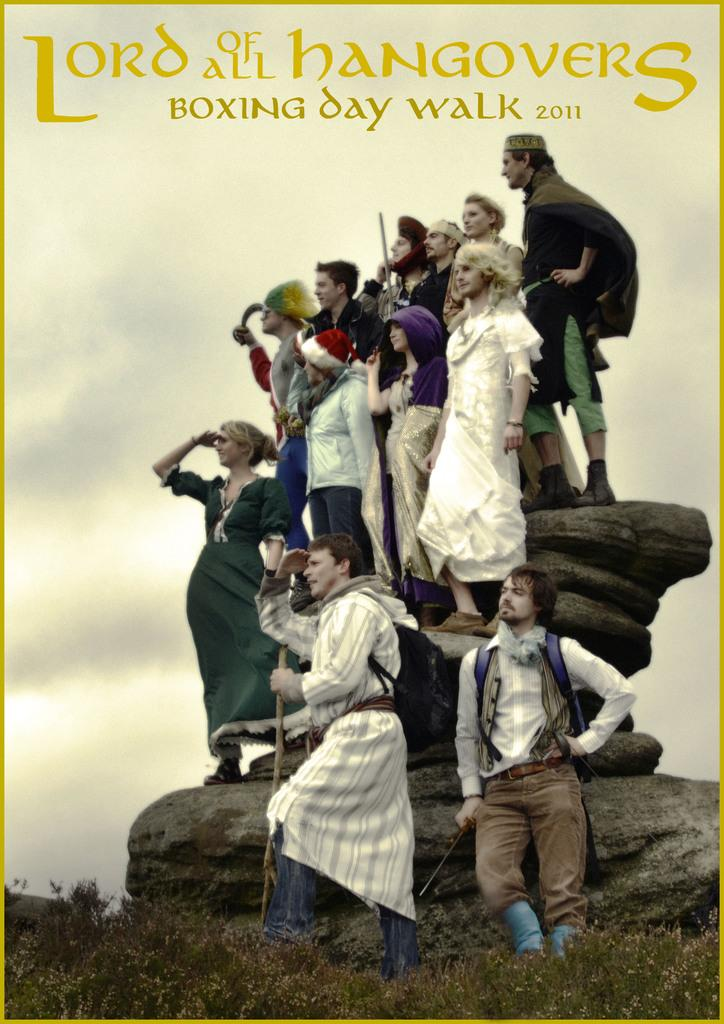What type of visual is depicted in the image? The image is a poster. What are the people in the poster doing? The people in the poster are standing on rocks. What type of vegetation is present in the poster? There is grass in the poster. What part of the natural environment is visible in the poster? The sky is visible in the poster. What additional elements are featured on the poster? There are words and numbers on the poster. Where is the cannon located in the poster? There is no cannon present in the poster. What type of sheet is covering the rocks in the poster? There is no sheet covering the rocks in the poster; the people are standing directly on the rocks. 